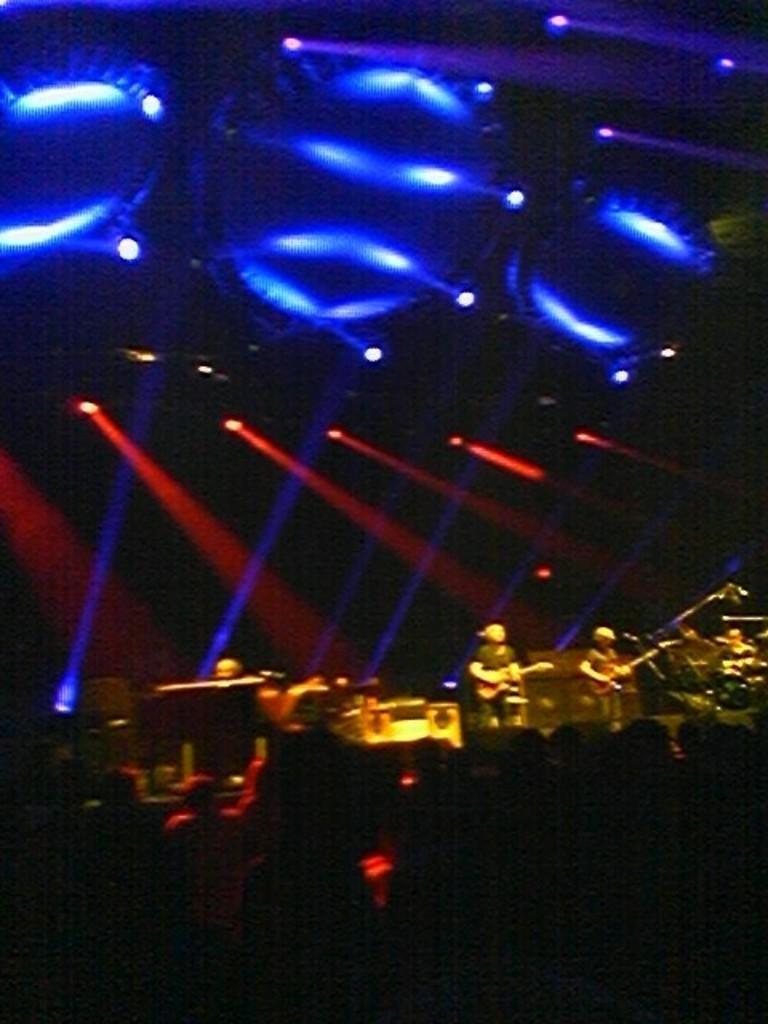Describe this image in one or two sentences. In this picture we can see a group of people, here we can see musical instruments, lights and some objects. 